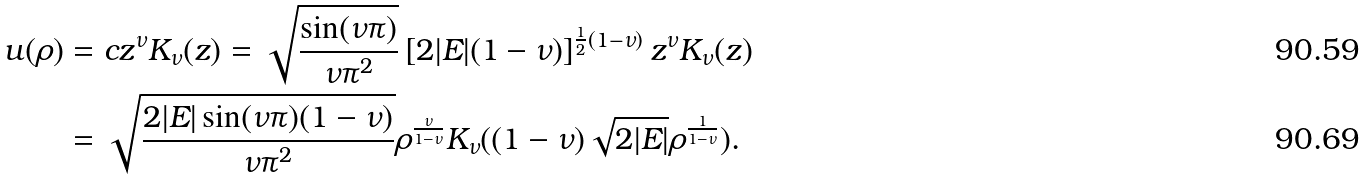<formula> <loc_0><loc_0><loc_500><loc_500>u ( \rho ) & = c z ^ { \nu } K _ { \nu } ( z ) = \sqrt { \frac { \sin ( \nu \pi ) } { \nu \pi ^ { 2 } } } \left [ 2 | E | ( 1 - \nu ) \right ] ^ { \frac { 1 } { 2 } ( 1 - \nu ) } z ^ { \nu } K _ { \nu } ( z ) \\ & = \sqrt { \frac { 2 | E | \sin ( \nu \pi ) ( 1 - \nu ) } { \nu \pi ^ { 2 } } } \rho ^ { \frac { \nu } { 1 - \nu } } K _ { \nu } ( ( 1 - \nu ) \sqrt { 2 | E | } \rho ^ { \frac { 1 } { 1 - \nu } } ) .</formula> 